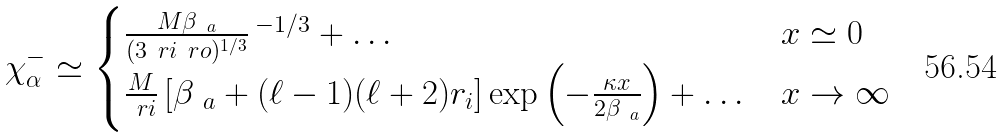<formula> <loc_0><loc_0><loc_500><loc_500>\chi _ { \alpha } ^ { - } \simeq \begin{cases} \frac { M \beta _ { \ a } } { ( 3 \ r i \ r o ) ^ { 1 / 3 } } \, ^ { - 1 / 3 } + \dots & x \simeq 0 \\ \frac { M } { \ r i } \left [ \beta _ { \ a } + ( \ell - 1 ) ( \ell + 2 ) r _ { i } \right ] \exp \left ( - \frac { \kappa x } { 2 \beta _ { \ a } } \right ) + \dots & x \to \infty \end{cases}</formula> 